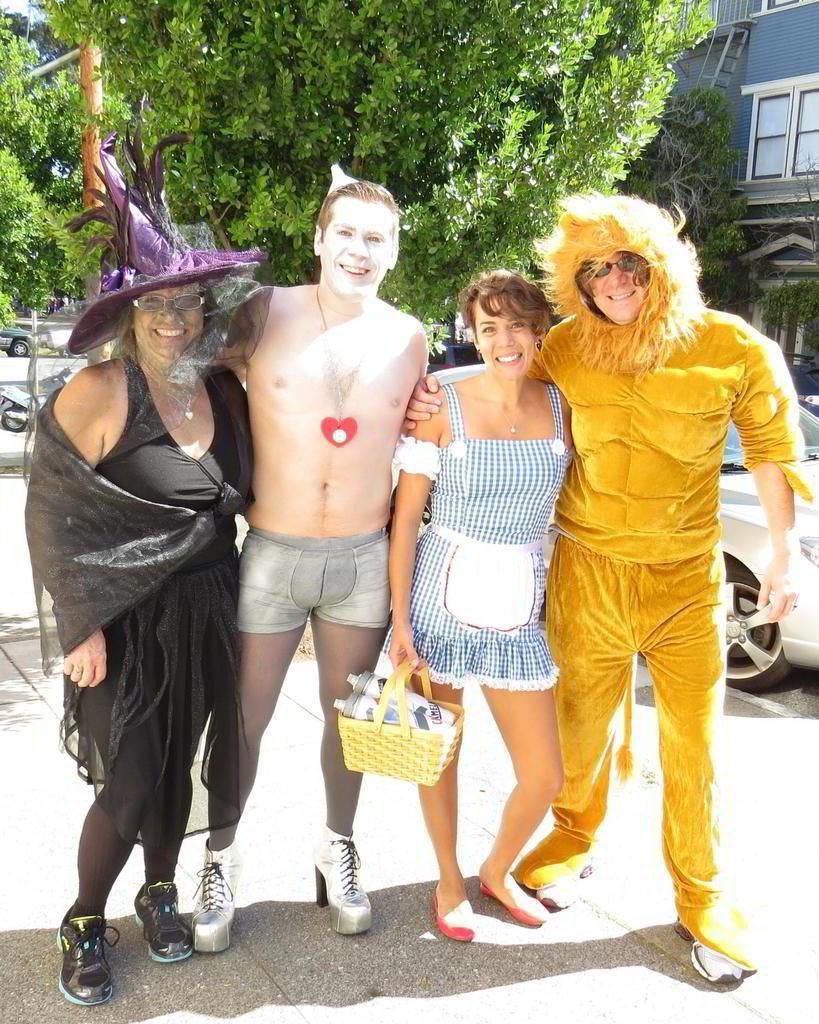Please provide a concise description of this image. In the center of the image we can see persons standing on the road. In the background there are trees, car, building and vehicle. 